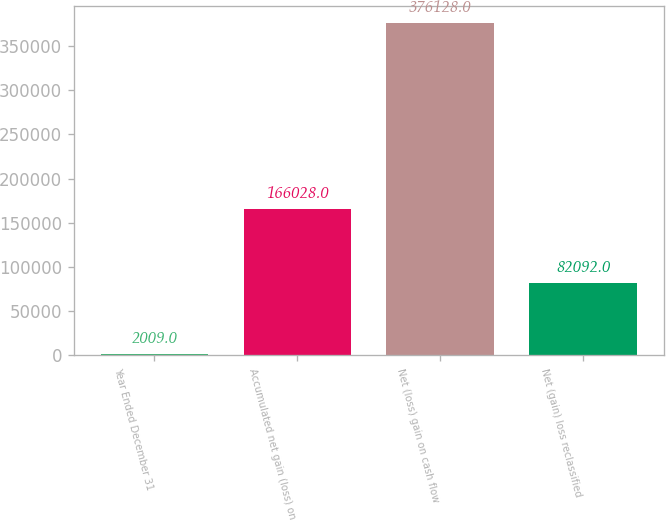Convert chart to OTSL. <chart><loc_0><loc_0><loc_500><loc_500><bar_chart><fcel>Year Ended December 31<fcel>Accumulated net gain (loss) on<fcel>Net (loss) gain on cash flow<fcel>Net (gain) loss reclassified<nl><fcel>2009<fcel>166028<fcel>376128<fcel>82092<nl></chart> 